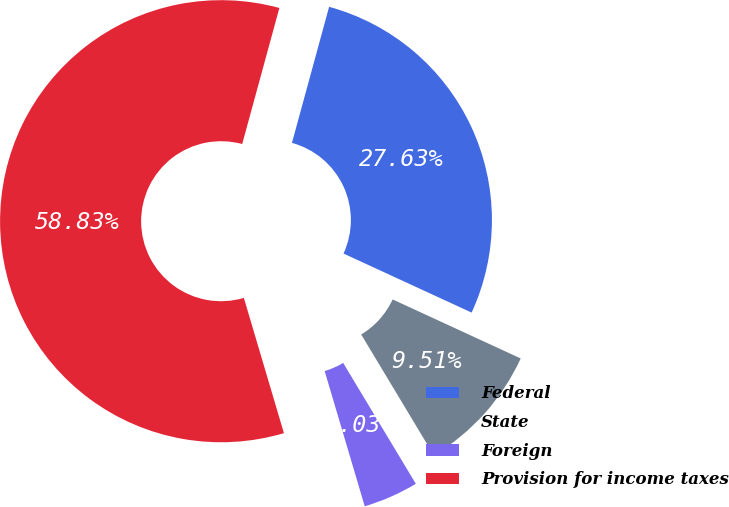<chart> <loc_0><loc_0><loc_500><loc_500><pie_chart><fcel>Federal<fcel>State<fcel>Foreign<fcel>Provision for income taxes<nl><fcel>27.63%<fcel>9.51%<fcel>4.03%<fcel>58.83%<nl></chart> 